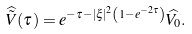Convert formula to latex. <formula><loc_0><loc_0><loc_500><loc_500>\widehat { \tilde { V } } ( \tau ) = e ^ { - \tau - | \xi | ^ { 2 } \left ( 1 - e ^ { - 2 \tau } \right ) } \widehat { V _ { 0 } } .</formula> 